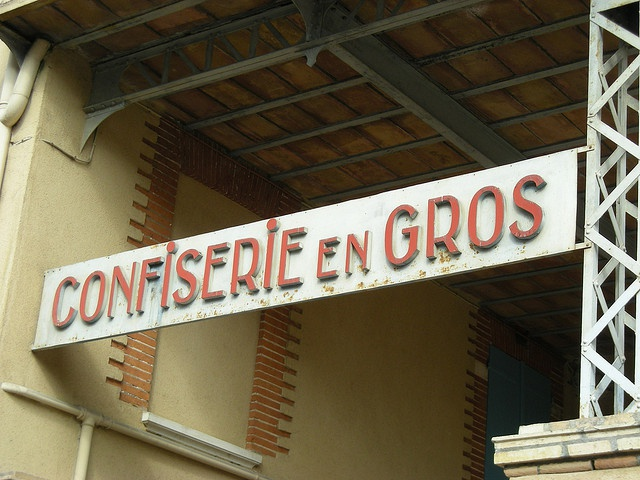Describe the objects in this image and their specific colors. I can see various objects in this image with different colors. 